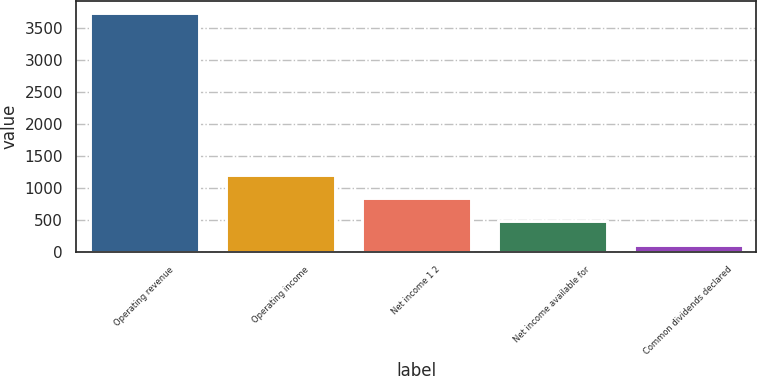Convert chart. <chart><loc_0><loc_0><loc_500><loc_500><bar_chart><fcel>Operating revenue<fcel>Operating income<fcel>Net income 1 2<fcel>Net income available for<fcel>Common dividends declared<nl><fcel>3731<fcel>1200.5<fcel>839<fcel>477.5<fcel>116<nl></chart> 